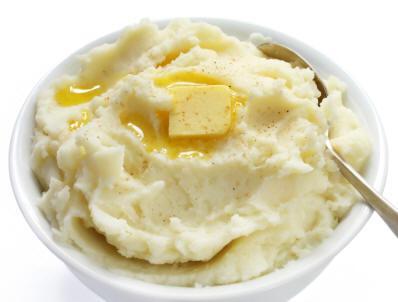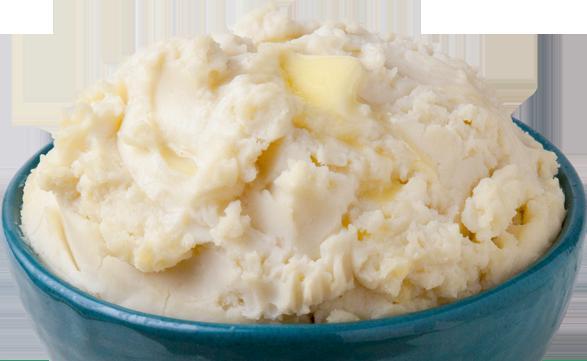The first image is the image on the left, the second image is the image on the right. Assess this claim about the two images: "One image shows mashed potatoes on a squarish plate garnished with green sprig.". Correct or not? Answer yes or no. No. 